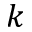Convert formula to latex. <formula><loc_0><loc_0><loc_500><loc_500>k</formula> 